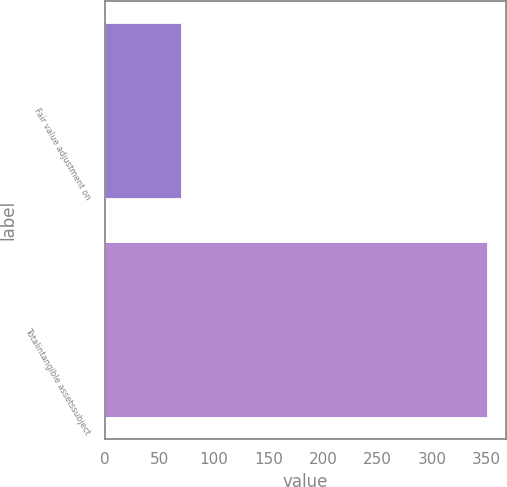Convert chart. <chart><loc_0><loc_0><loc_500><loc_500><bar_chart><fcel>Fair value adjustment on<fcel>Totalintangible assetssubject<nl><fcel>70<fcel>350<nl></chart> 